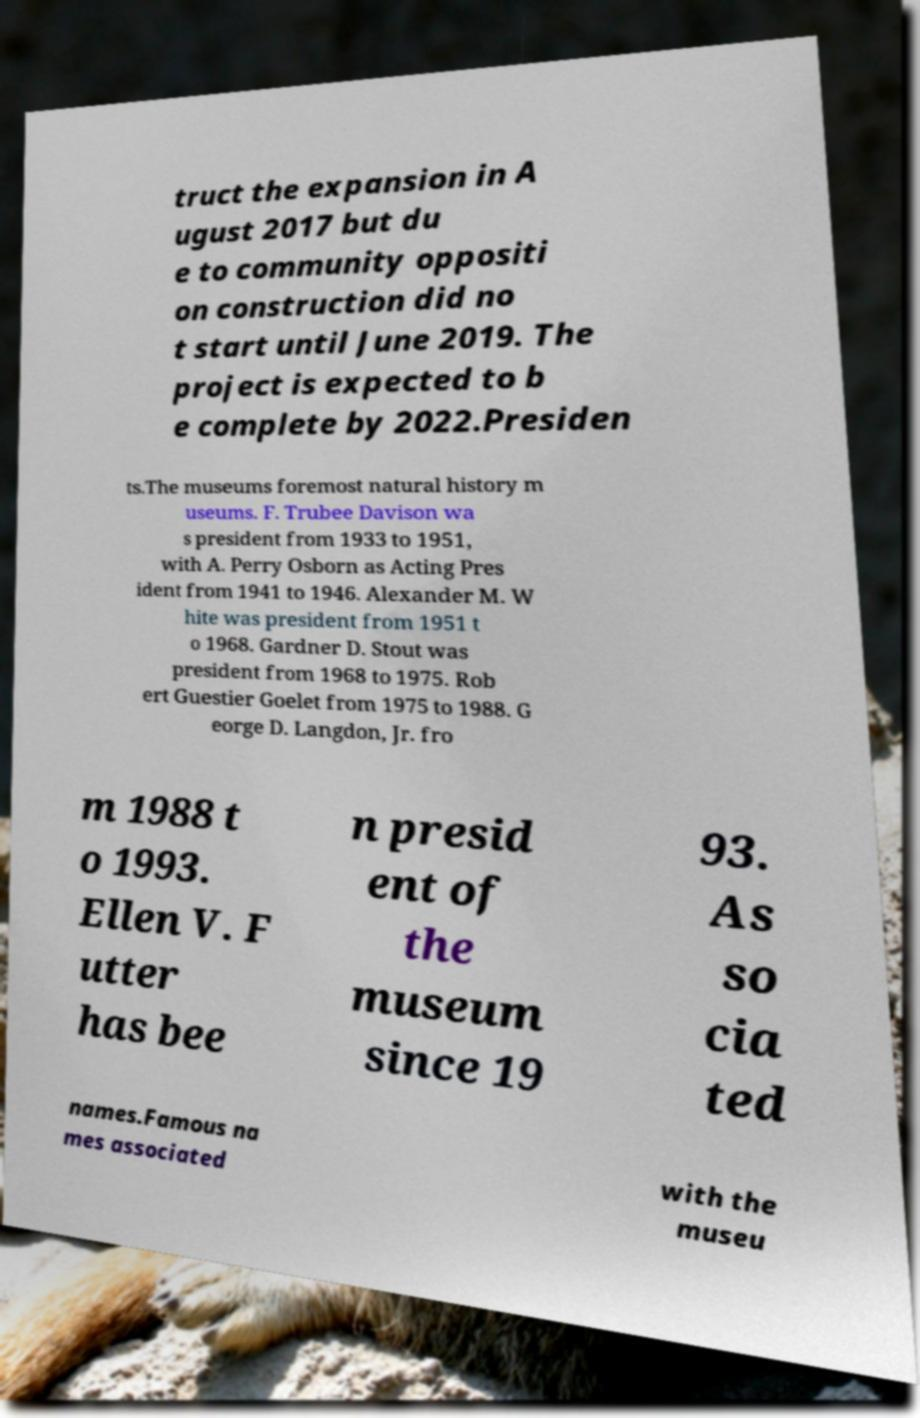Can you accurately transcribe the text from the provided image for me? truct the expansion in A ugust 2017 but du e to community oppositi on construction did no t start until June 2019. The project is expected to b e complete by 2022.Presiden ts.The museums foremost natural history m useums. F. Trubee Davison wa s president from 1933 to 1951, with A. Perry Osborn as Acting Pres ident from 1941 to 1946. Alexander M. W hite was president from 1951 t o 1968. Gardner D. Stout was president from 1968 to 1975. Rob ert Guestier Goelet from 1975 to 1988. G eorge D. Langdon, Jr. fro m 1988 t o 1993. Ellen V. F utter has bee n presid ent of the museum since 19 93. As so cia ted names.Famous na mes associated with the museu 